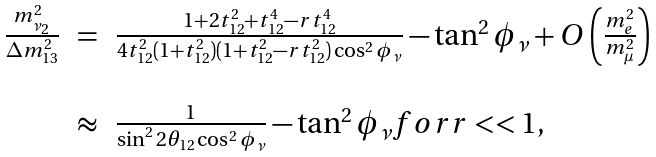<formula> <loc_0><loc_0><loc_500><loc_500>\begin{array} { l l l } \frac { m _ { \nu _ { 2 } } ^ { 2 } } { \Delta m ^ { 2 } _ { 1 3 } } & = & \frac { 1 + 2 t _ { 1 2 } ^ { 2 } + t ^ { 4 } _ { 1 2 } - r t ^ { 4 } _ { 1 2 } } { 4 t ^ { 2 } _ { 1 2 } ( 1 + t ^ { 2 } _ { 1 2 } ) ( 1 + t ^ { 2 } _ { 1 2 } - r t ^ { 2 } _ { 1 2 } ) \cos ^ { 2 } \phi _ { \nu } } - \tan ^ { 2 } \phi _ { \nu } + O \left ( \frac { m _ { e } ^ { 2 } } { m _ { \mu } ^ { 2 } } \right ) \\ \\ & \approx & \frac { 1 } { \sin ^ { 2 } 2 \theta _ { 1 2 } \cos ^ { 2 } \phi _ { \nu } } - \tan ^ { 2 } \phi _ { \nu } f o r r < < 1 , \end{array}</formula> 